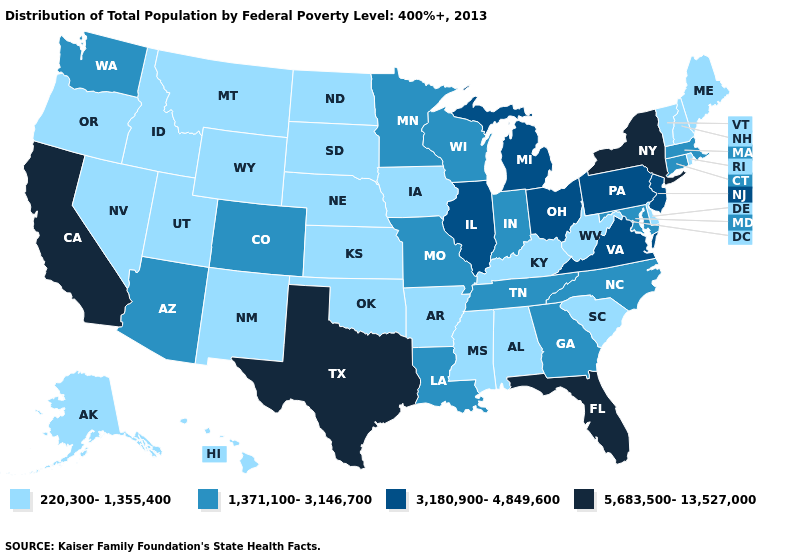What is the lowest value in the USA?
Write a very short answer. 220,300-1,355,400. Name the states that have a value in the range 5,683,500-13,527,000?
Concise answer only. California, Florida, New York, Texas. What is the lowest value in the USA?
Answer briefly. 220,300-1,355,400. What is the value of Idaho?
Keep it brief. 220,300-1,355,400. What is the value of Indiana?
Short answer required. 1,371,100-3,146,700. Does Oregon have the highest value in the West?
Concise answer only. No. What is the highest value in the South ?
Answer briefly. 5,683,500-13,527,000. Does New York have the highest value in the Northeast?
Give a very brief answer. Yes. Is the legend a continuous bar?
Write a very short answer. No. Name the states that have a value in the range 220,300-1,355,400?
Concise answer only. Alabama, Alaska, Arkansas, Delaware, Hawaii, Idaho, Iowa, Kansas, Kentucky, Maine, Mississippi, Montana, Nebraska, Nevada, New Hampshire, New Mexico, North Dakota, Oklahoma, Oregon, Rhode Island, South Carolina, South Dakota, Utah, Vermont, West Virginia, Wyoming. What is the value of North Dakota?
Be succinct. 220,300-1,355,400. Which states have the highest value in the USA?
Concise answer only. California, Florida, New York, Texas. Name the states that have a value in the range 3,180,900-4,849,600?
Quick response, please. Illinois, Michigan, New Jersey, Ohio, Pennsylvania, Virginia. What is the value of Rhode Island?
Quick response, please. 220,300-1,355,400. Name the states that have a value in the range 1,371,100-3,146,700?
Quick response, please. Arizona, Colorado, Connecticut, Georgia, Indiana, Louisiana, Maryland, Massachusetts, Minnesota, Missouri, North Carolina, Tennessee, Washington, Wisconsin. 